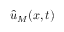Convert formula to latex. <formula><loc_0><loc_0><loc_500><loc_500>\hat { u } _ { M } ( x , t )</formula> 